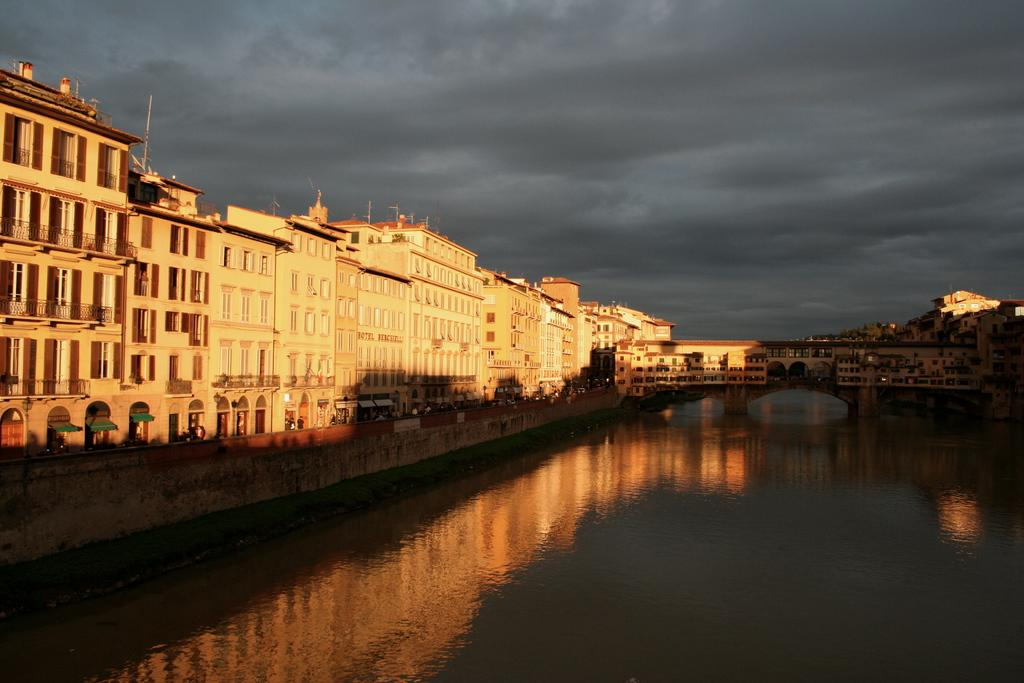What can be seen on the right side of the image in the foreground? There is water in the foreground of the image on the right side. What is located on the left side of the image? There are buildings on the left side of the image. Are there any buildings visible in the background of the image? Yes, buildings are also present in the background of the image. What is visible at the top of the image? The sky is visible at the top of the image. Can you describe the sky in the image? The sky has a cloud in it. How many fingers can be seen pointing at the buildings in the image? There are no fingers visible in the image pointing at the buildings. What type of feeling is expressed by the cloud in the image? The cloud in the image is not expressing any feelings, as it is an inanimate object. 